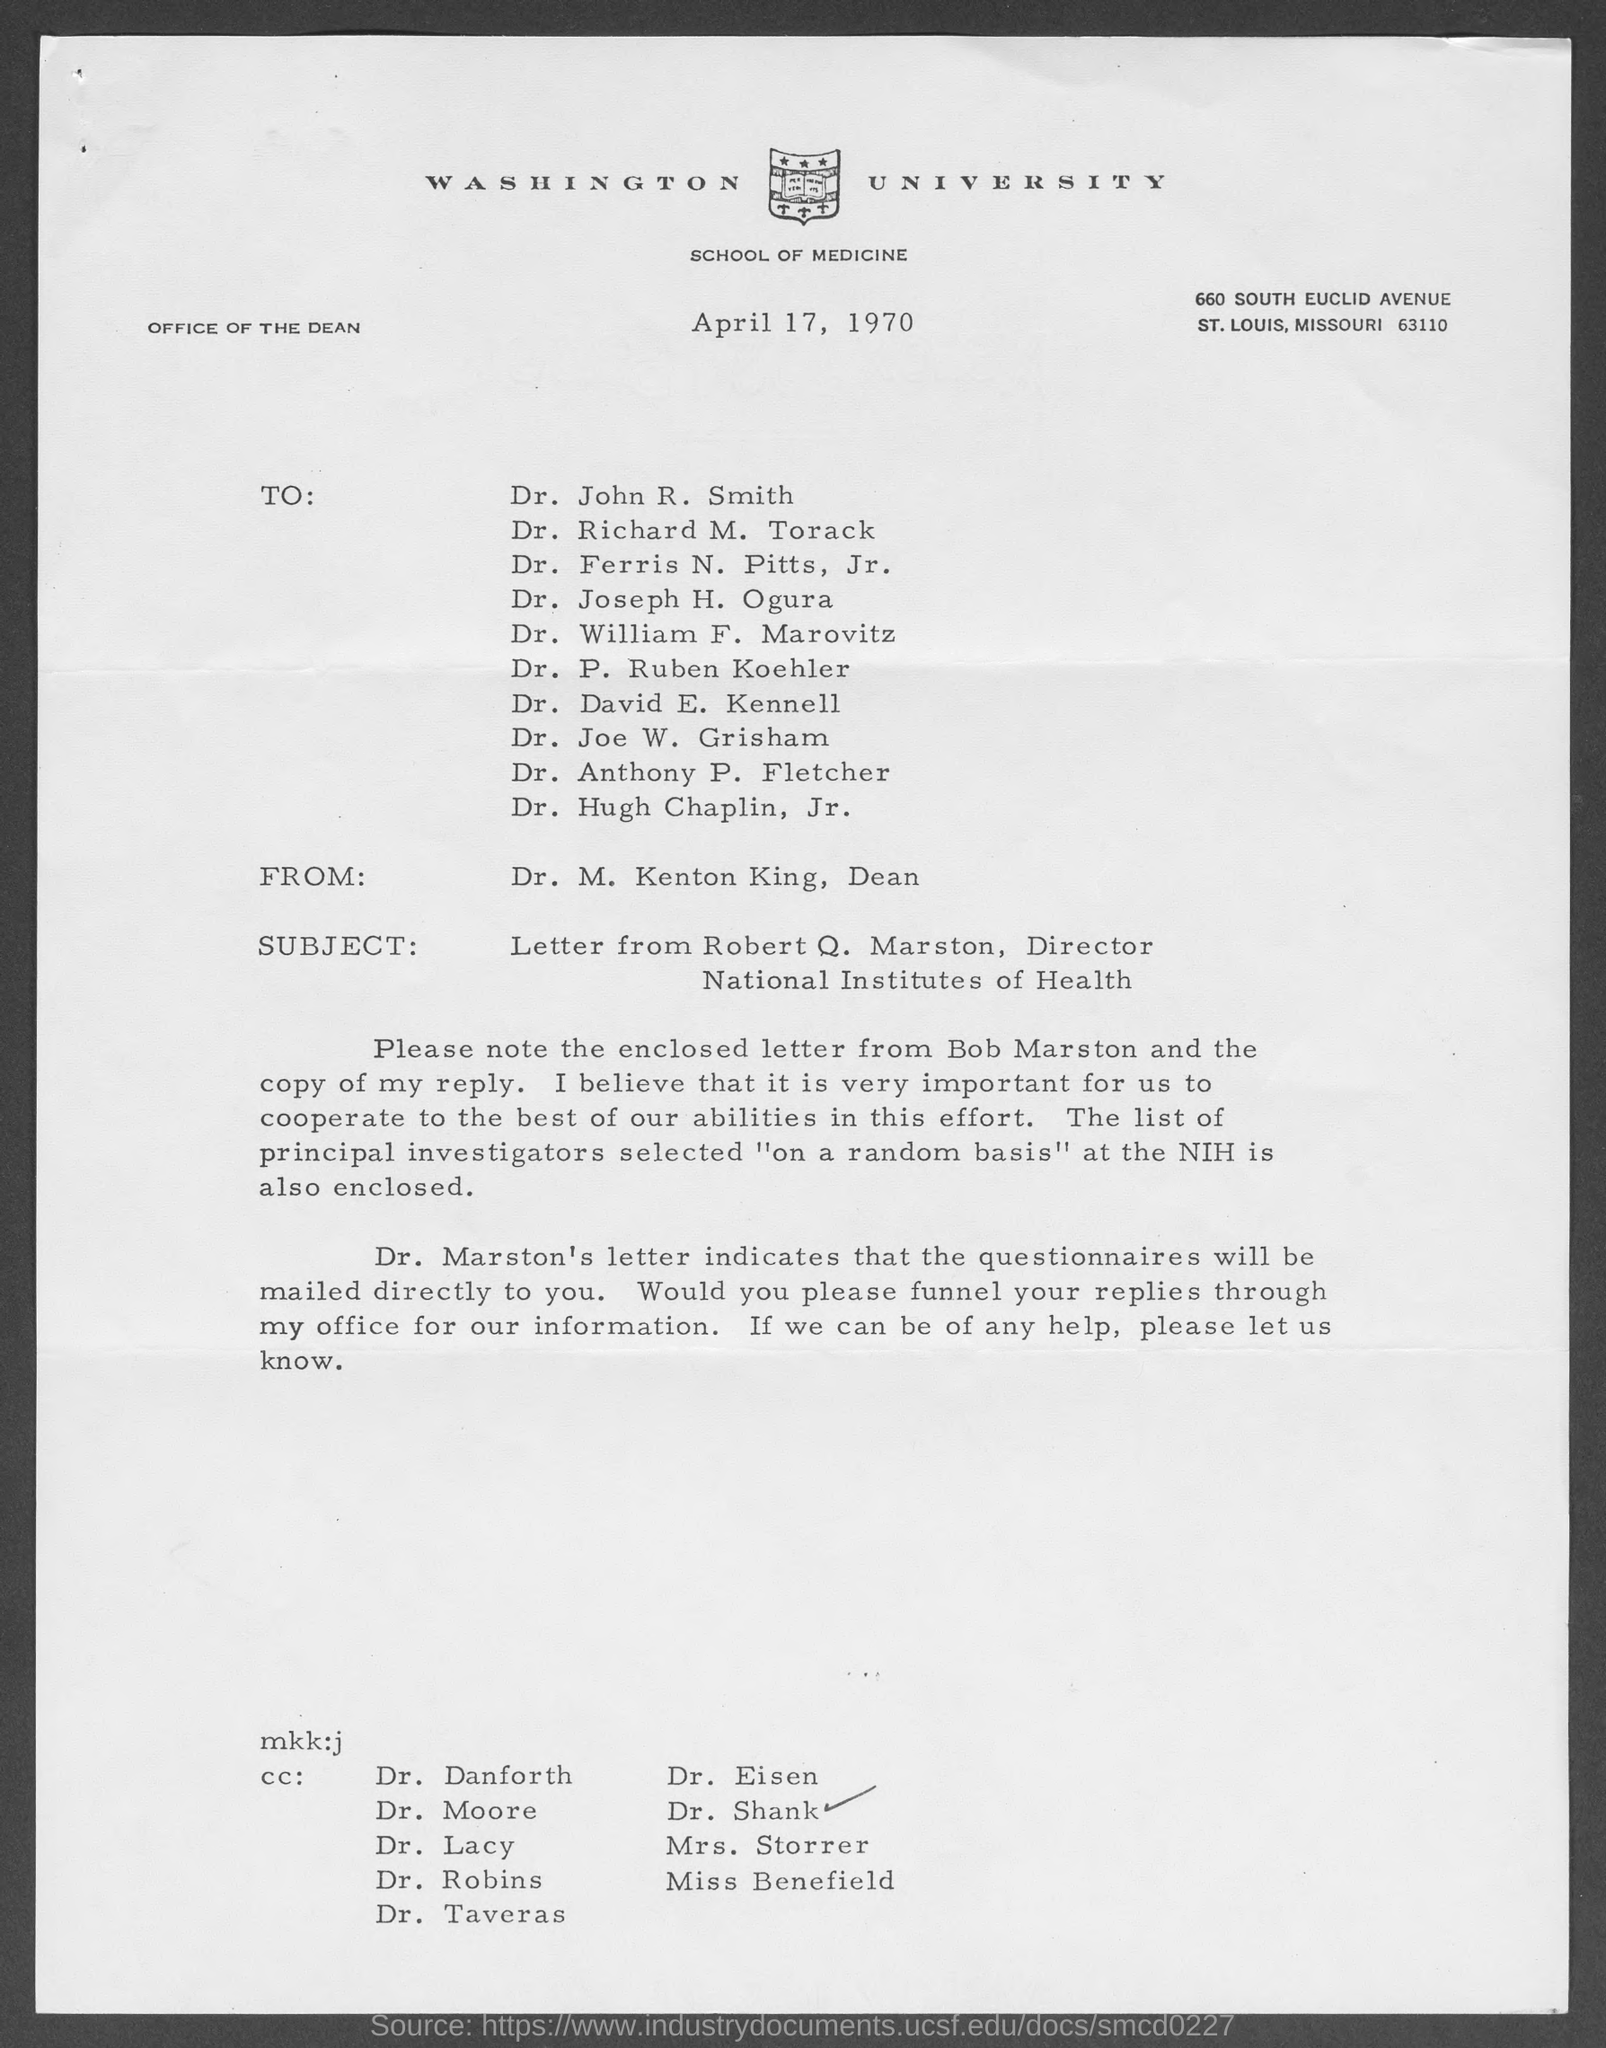Which University is mentioned in the letter head?
Give a very brief answer. WASHINGTON UNIVERSITY. What is the subject mentioned in this letter?
Give a very brief answer. Letter from Robert Q. Marston, Director National Institutes of health. What is the date mentioned in this letter?
Your response must be concise. April 17, 1970. 